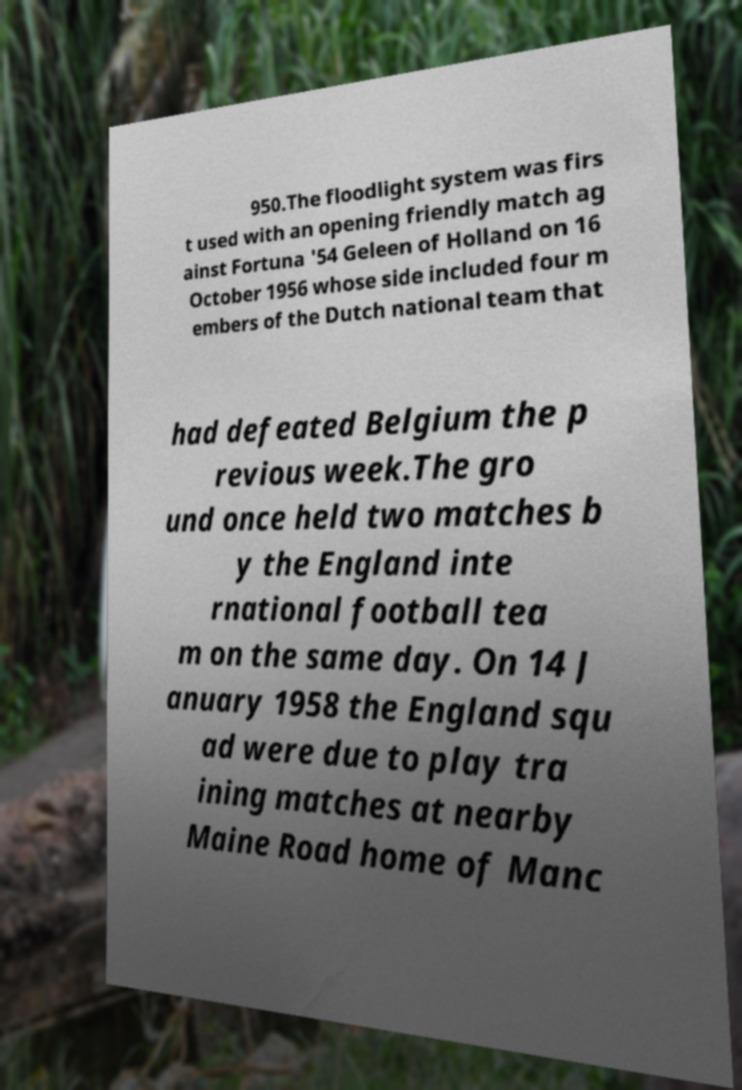For documentation purposes, I need the text within this image transcribed. Could you provide that? 950.The floodlight system was firs t used with an opening friendly match ag ainst Fortuna '54 Geleen of Holland on 16 October 1956 whose side included four m embers of the Dutch national team that had defeated Belgium the p revious week.The gro und once held two matches b y the England inte rnational football tea m on the same day. On 14 J anuary 1958 the England squ ad were due to play tra ining matches at nearby Maine Road home of Manc 